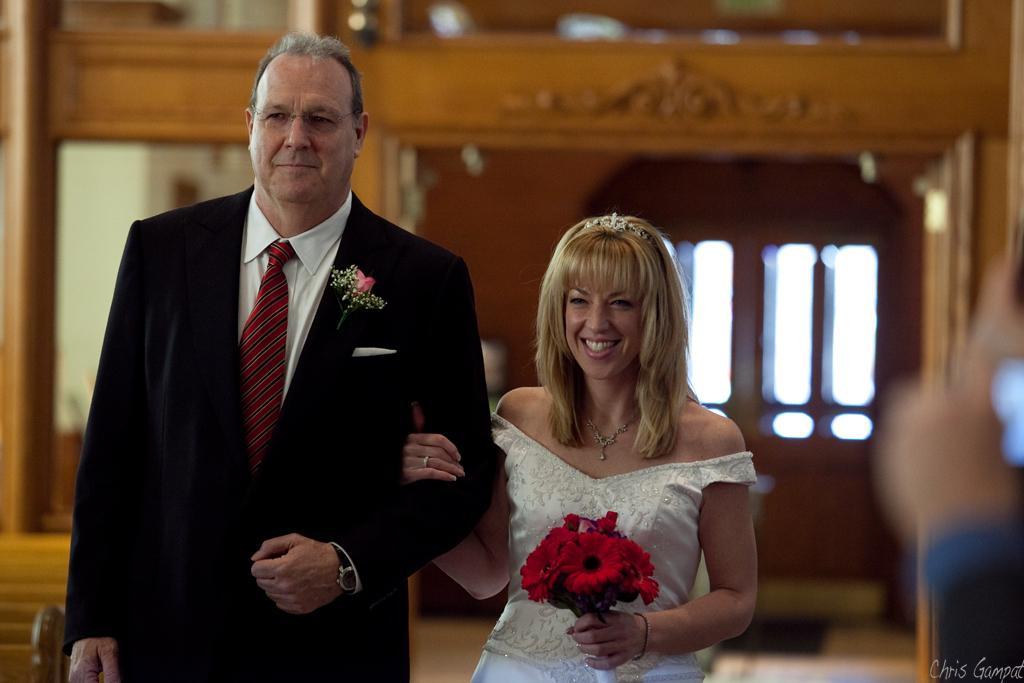Can you describe this image briefly? In this image I can see a man and a woman are standing. I can see smile on her face and I can see she is holding red colour flowers. I can see she is wearing white dress and he is wearing black blazer, red tie, white shirt and specs. I can also see this image is little bit blurry from background. 